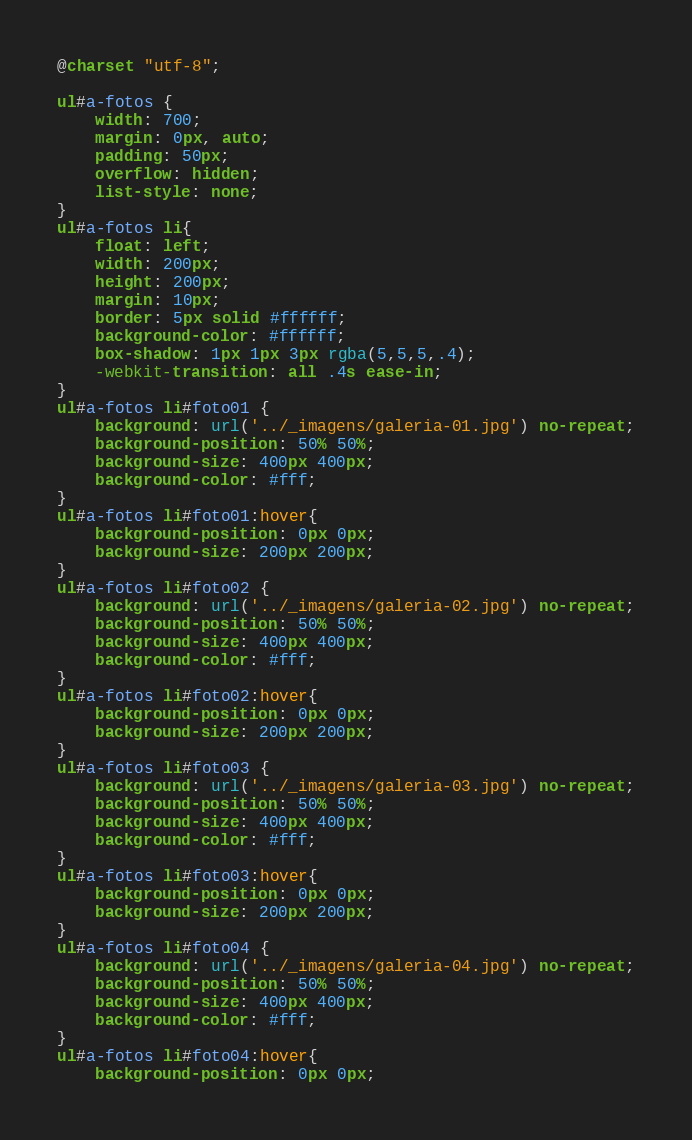Convert code to text. <code><loc_0><loc_0><loc_500><loc_500><_CSS_>@charset "utf-8";

ul#a-fotos {
	width: 700;
	margin: 0px, auto;
	padding: 50px;
	overflow: hidden;
	list-style: none;	
}
ul#a-fotos li{
	float: left;
	width: 200px;
	height: 200px;
	margin: 10px;
	border: 5px solid #ffffff;
	background-color: #ffffff;
	box-shadow: 1px 1px 3px rgba(5,5,5,.4);
	-webkit-transition: all .4s ease-in; 
}
ul#a-fotos li#foto01 {
	background: url('../_imagens/galeria-01.jpg') no-repeat;
	background-position: 50% 50%;
	background-size: 400px 400px;
	background-color: #fff;
}
ul#a-fotos li#foto01:hover{
	background-position: 0px 0px;
	background-size: 200px 200px;
}
ul#a-fotos li#foto02 {
	background: url('../_imagens/galeria-02.jpg') no-repeat;
	background-position: 50% 50%;
	background-size: 400px 400px;
	background-color: #fff;
}
ul#a-fotos li#foto02:hover{
	background-position: 0px 0px;
	background-size: 200px 200px;
}
ul#a-fotos li#foto03 {
	background: url('../_imagens/galeria-03.jpg') no-repeat;
	background-position: 50% 50%;
	background-size: 400px 400px;
	background-color: #fff;
}
ul#a-fotos li#foto03:hover{
	background-position: 0px 0px;
	background-size: 200px 200px;
}
ul#a-fotos li#foto04 {
	background: url('../_imagens/galeria-04.jpg') no-repeat;
	background-position: 50% 50%;
	background-size: 400px 400px;
	background-color: #fff;
}
ul#a-fotos li#foto04:hover{
	background-position: 0px 0px;</code> 